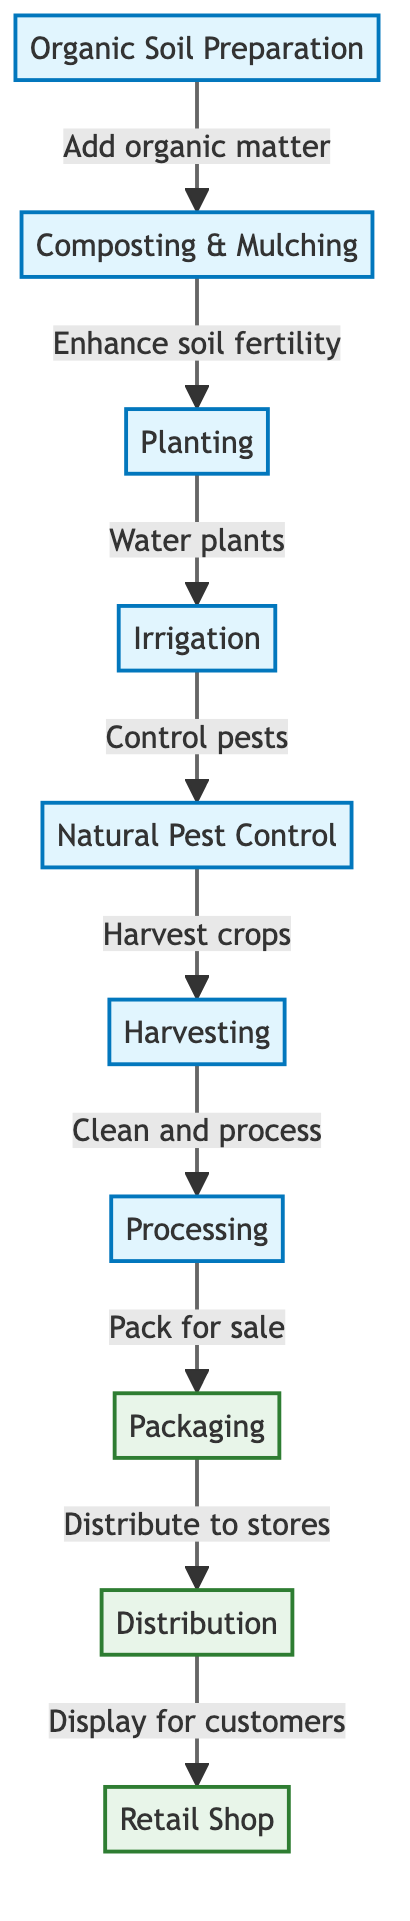What is the first step in the cycle of organic farming? The first step, as indicated in the diagram, is "Organic Soil Preparation," which is the foundational process that begins the organic farming cycle.
Answer: Organic Soil Preparation How many processes are involved in the organic farming cycle before distribution? By counting the nodes labeled with "process" (Organic Soil Preparation, Composting & Mulching, Planting, Irrigation, Natural Pest Control, Harvesting, Processing), we find there are seven processes before reaching the distribution phase.
Answer: Seven What does "Composting & Mulching" enhance? The diagram shows that "Composting & Mulching" enhances "soil fertility," highlighting its role in enriching the soil for better plant growth.
Answer: Soil fertility Which step directly follows "Natural Pest Control"? According to the arrows in the diagram, "Natural Pest Control" is followed by "Harvesting," indicating the order of tasks in the organic farming cycle.
Answer: Harvesting How many distribution steps are there after processing? There are three steps following "Processing" (Packaging, Distribution, and Retail Shop), demonstrating the stages products go through before reaching the customer.
Answer: Three What is the relationship between "Harvesting" and "Processing"? The relationship is sequential, as the diagram shows that after "Harvesting," the next step is "Processing," indicating that harvested crops are then cleaned and prepared for sale.
Answer: Sequential Which activity involves controlling pests? The activity of "Natural Pest Control" is responsible for the function of controlling pests as depicted in the diagram.
Answer: Natural Pest Control What is packed for sale after the processing stage? The diagram indicates that after "Processing," the next task is "Packaging," which specifies that the clean and processed products are packed for sale.
Answer: Pack for sale 